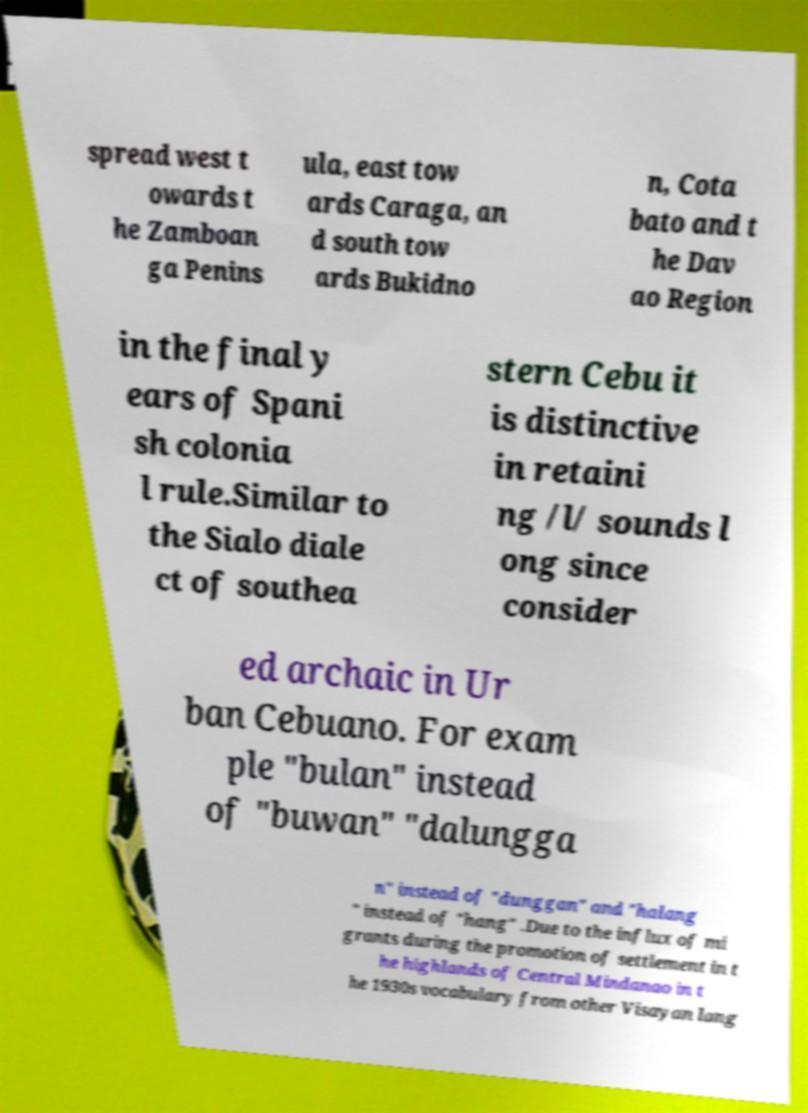I need the written content from this picture converted into text. Can you do that? spread west t owards t he Zamboan ga Penins ula, east tow ards Caraga, an d south tow ards Bukidno n, Cota bato and t he Dav ao Region in the final y ears of Spani sh colonia l rule.Similar to the Sialo diale ct of southea stern Cebu it is distinctive in retaini ng /l/ sounds l ong since consider ed archaic in Ur ban Cebuano. For exam ple "bulan" instead of "buwan" "dalungga n" instead of "dunggan" and "halang " instead of "hang" .Due to the influx of mi grants during the promotion of settlement in t he highlands of Central Mindanao in t he 1930s vocabulary from other Visayan lang 